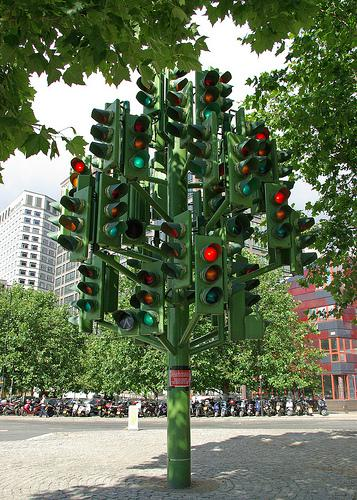Question: where was the photo taken?
Choices:
A. The forrest.
B. The zoo.
C. City.
D. The circus.
Answer with the letter. Answer: C Question: what is in the background?
Choices:
A. Mountains.
B. Buildings.
C. A field.
D. A stadium.
Answer with the letter. Answer: B Question: what is the picture of?
Choices:
A. Cupcakes.
B. Babies.
C. Stoplights.
D. Baseball game.
Answer with the letter. Answer: C Question: how many buildings can you see?
Choices:
A. 12.
B. 13.
C. 5.
D. 4.
Answer with the letter. Answer: D 